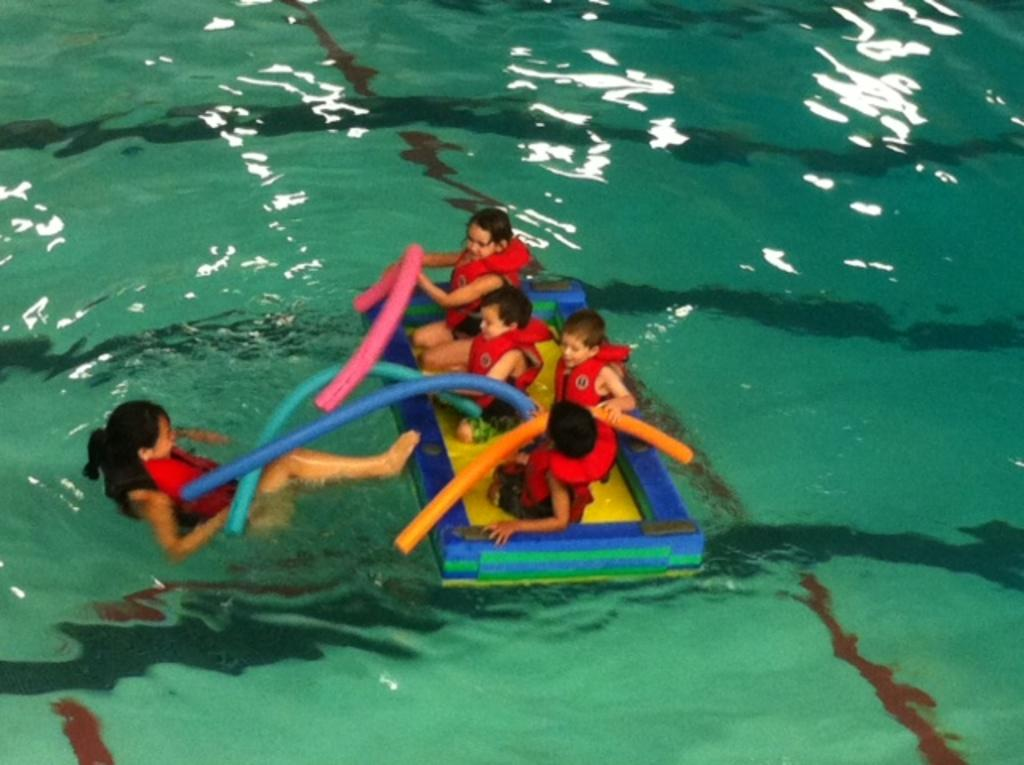What are the people doing in the image? The people are sitting on an object in the image. Where is the object located? The object is on the water. What colors can be seen on the object? The object has blue and yellow colors. What are the people wearing? The people are wearing red color jackets. What are the people holding? The people are holding colorful tubes. What type of waste can be seen floating in the water near the object? There is no waste visible in the image; it only shows people sitting on an object with colorful tubes. 